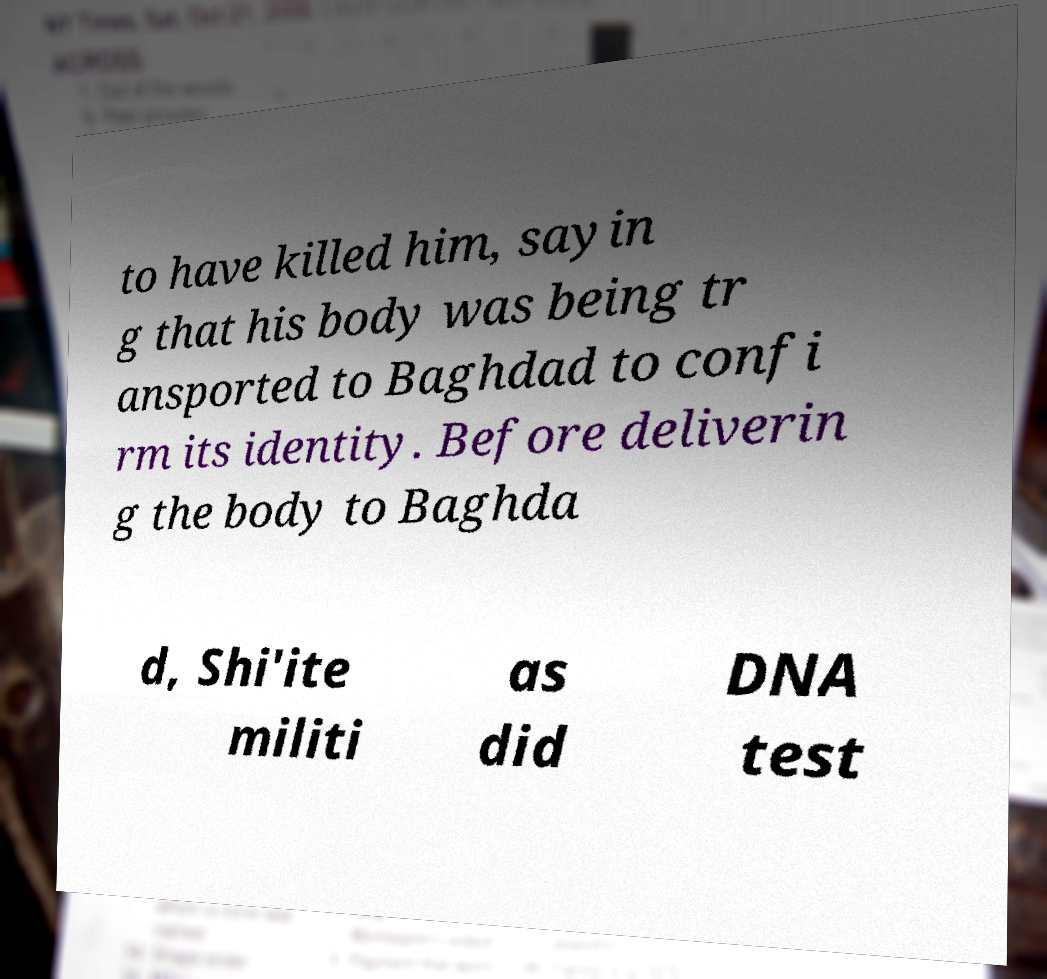Can you accurately transcribe the text from the provided image for me? to have killed him, sayin g that his body was being tr ansported to Baghdad to confi rm its identity. Before deliverin g the body to Baghda d, Shi'ite militi as did DNA test 